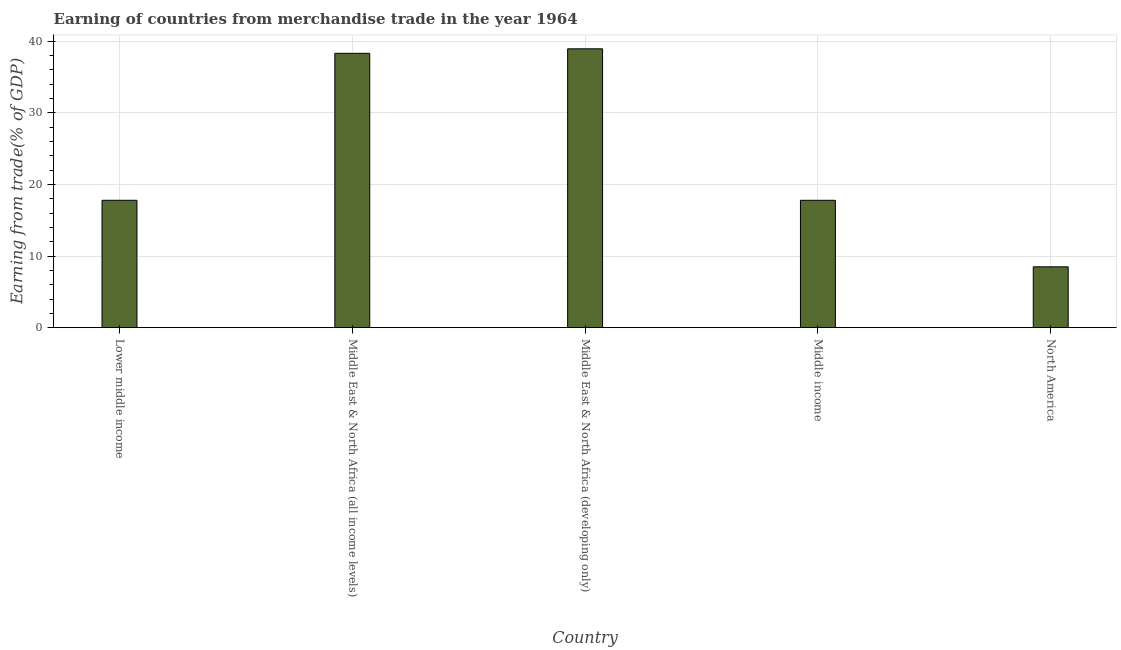Does the graph contain grids?
Ensure brevity in your answer.  Yes. What is the title of the graph?
Offer a very short reply. Earning of countries from merchandise trade in the year 1964. What is the label or title of the X-axis?
Your answer should be compact. Country. What is the label or title of the Y-axis?
Ensure brevity in your answer.  Earning from trade(% of GDP). What is the earning from merchandise trade in Lower middle income?
Give a very brief answer. 17.79. Across all countries, what is the maximum earning from merchandise trade?
Make the answer very short. 38.94. Across all countries, what is the minimum earning from merchandise trade?
Your answer should be compact. 8.5. In which country was the earning from merchandise trade maximum?
Keep it short and to the point. Middle East & North Africa (developing only). In which country was the earning from merchandise trade minimum?
Keep it short and to the point. North America. What is the sum of the earning from merchandise trade?
Provide a succinct answer. 121.32. What is the difference between the earning from merchandise trade in Middle East & North Africa (all income levels) and North America?
Provide a short and direct response. 29.81. What is the average earning from merchandise trade per country?
Provide a succinct answer. 24.26. What is the median earning from merchandise trade?
Give a very brief answer. 17.79. What is the ratio of the earning from merchandise trade in Middle income to that in North America?
Ensure brevity in your answer.  2.09. Is the difference between the earning from merchandise trade in Lower middle income and Middle East & North Africa (all income levels) greater than the difference between any two countries?
Provide a succinct answer. No. What is the difference between the highest and the second highest earning from merchandise trade?
Ensure brevity in your answer.  0.63. Is the sum of the earning from merchandise trade in Lower middle income and North America greater than the maximum earning from merchandise trade across all countries?
Offer a terse response. No. What is the difference between the highest and the lowest earning from merchandise trade?
Give a very brief answer. 30.44. In how many countries, is the earning from merchandise trade greater than the average earning from merchandise trade taken over all countries?
Your answer should be compact. 2. How many bars are there?
Your response must be concise. 5. How many countries are there in the graph?
Ensure brevity in your answer.  5. What is the Earning from trade(% of GDP) in Lower middle income?
Offer a very short reply. 17.79. What is the Earning from trade(% of GDP) in Middle East & North Africa (all income levels)?
Your response must be concise. 38.31. What is the Earning from trade(% of GDP) in Middle East & North Africa (developing only)?
Give a very brief answer. 38.94. What is the Earning from trade(% of GDP) of Middle income?
Your answer should be very brief. 17.79. What is the Earning from trade(% of GDP) in North America?
Keep it short and to the point. 8.5. What is the difference between the Earning from trade(% of GDP) in Lower middle income and Middle East & North Africa (all income levels)?
Ensure brevity in your answer.  -20.52. What is the difference between the Earning from trade(% of GDP) in Lower middle income and Middle East & North Africa (developing only)?
Give a very brief answer. -21.15. What is the difference between the Earning from trade(% of GDP) in Lower middle income and Middle income?
Provide a succinct answer. 0. What is the difference between the Earning from trade(% of GDP) in Lower middle income and North America?
Offer a terse response. 9.29. What is the difference between the Earning from trade(% of GDP) in Middle East & North Africa (all income levels) and Middle East & North Africa (developing only)?
Offer a very short reply. -0.63. What is the difference between the Earning from trade(% of GDP) in Middle East & North Africa (all income levels) and Middle income?
Ensure brevity in your answer.  20.52. What is the difference between the Earning from trade(% of GDP) in Middle East & North Africa (all income levels) and North America?
Provide a short and direct response. 29.81. What is the difference between the Earning from trade(% of GDP) in Middle East & North Africa (developing only) and Middle income?
Provide a succinct answer. 21.15. What is the difference between the Earning from trade(% of GDP) in Middle East & North Africa (developing only) and North America?
Make the answer very short. 30.44. What is the difference between the Earning from trade(% of GDP) in Middle income and North America?
Provide a short and direct response. 9.29. What is the ratio of the Earning from trade(% of GDP) in Lower middle income to that in Middle East & North Africa (all income levels)?
Your response must be concise. 0.46. What is the ratio of the Earning from trade(% of GDP) in Lower middle income to that in Middle East & North Africa (developing only)?
Your answer should be very brief. 0.46. What is the ratio of the Earning from trade(% of GDP) in Lower middle income to that in North America?
Offer a terse response. 2.09. What is the ratio of the Earning from trade(% of GDP) in Middle East & North Africa (all income levels) to that in Middle income?
Your response must be concise. 2.15. What is the ratio of the Earning from trade(% of GDP) in Middle East & North Africa (all income levels) to that in North America?
Offer a terse response. 4.51. What is the ratio of the Earning from trade(% of GDP) in Middle East & North Africa (developing only) to that in Middle income?
Your response must be concise. 2.19. What is the ratio of the Earning from trade(% of GDP) in Middle East & North Africa (developing only) to that in North America?
Your answer should be very brief. 4.58. What is the ratio of the Earning from trade(% of GDP) in Middle income to that in North America?
Provide a short and direct response. 2.09. 